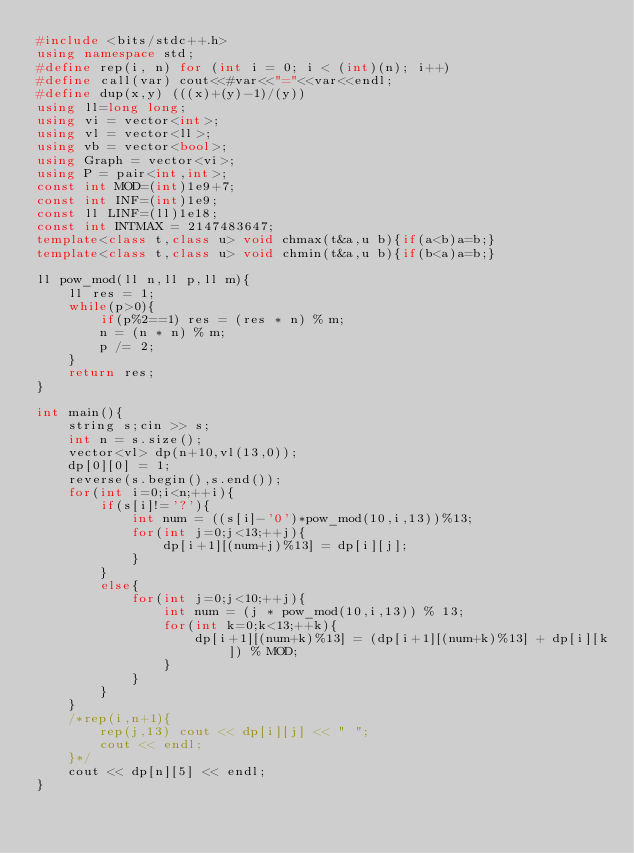Convert code to text. <code><loc_0><loc_0><loc_500><loc_500><_C++_>#include <bits/stdc++.h>
using namespace std;
#define rep(i, n) for (int i = 0; i < (int)(n); i++)
#define call(var) cout<<#var<<"="<<var<<endl;
#define dup(x,y) (((x)+(y)-1)/(y))
using ll=long long;
using vi = vector<int>;
using vl = vector<ll>;
using vb = vector<bool>;
using Graph = vector<vi>;
using P = pair<int,int>;
const int MOD=(int)1e9+7;
const int INF=(int)1e9;
const ll LINF=(ll)1e18;
const int INTMAX = 2147483647;
template<class t,class u> void chmax(t&a,u b){if(a<b)a=b;}
template<class t,class u> void chmin(t&a,u b){if(b<a)a=b;}

ll pow_mod(ll n,ll p,ll m){
    ll res = 1;
    while(p>0){
        if(p%2==1) res = (res * n) % m;
        n = (n * n) % m;
        p /= 2;
    }
    return res;
}

int main(){
    string s;cin >> s;
    int n = s.size();
    vector<vl> dp(n+10,vl(13,0));
    dp[0][0] = 1;
    reverse(s.begin(),s.end());
    for(int i=0;i<n;++i){
        if(s[i]!='?'){
            int num = ((s[i]-'0')*pow_mod(10,i,13))%13;
            for(int j=0;j<13;++j){
                dp[i+1][(num+j)%13] = dp[i][j];
            }
        }
        else{
            for(int j=0;j<10;++j){
                int num = (j * pow_mod(10,i,13)) % 13;
                for(int k=0;k<13;++k){
                    dp[i+1][(num+k)%13] = (dp[i+1][(num+k)%13] + dp[i][k]) % MOD;
                }
            }
        }
    }
    /*rep(i,n+1){
        rep(j,13) cout << dp[i][j] << " ";
        cout << endl;
    }*/
    cout << dp[n][5] << endl;
}</code> 